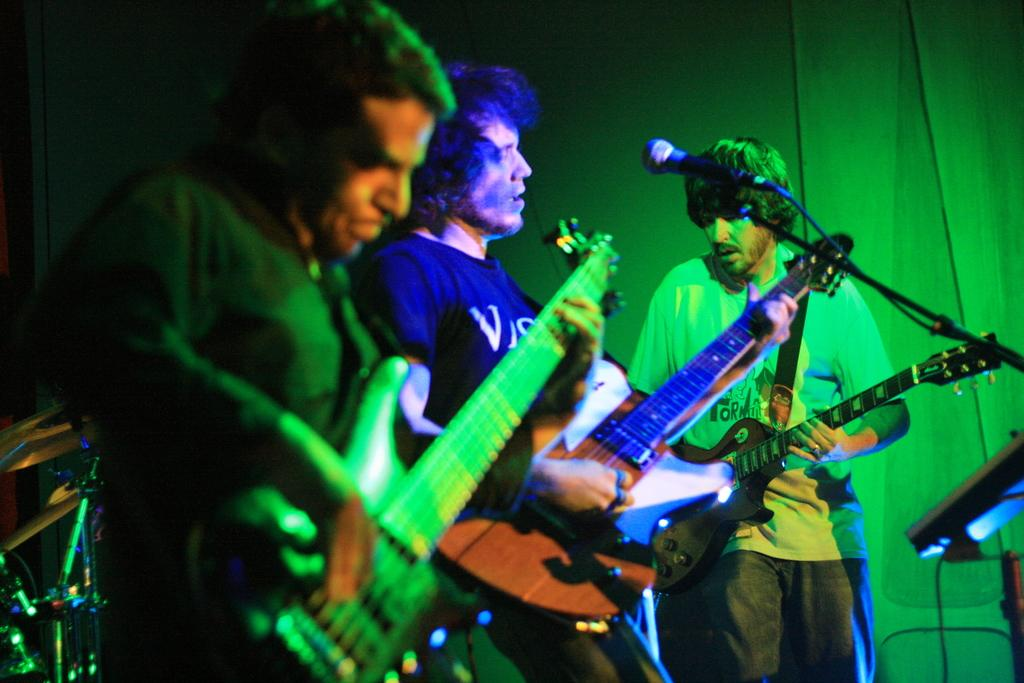How many people are in the image? There are three persons in the image. What are the three persons doing? They are playing guitar. Can you describe the middle person in the image? The middle person is holding a microphone. What type of quartz can be seen in the image? There is no quartz present in the image. What day of the week is depicted in the image? The image does not show a calendar or any indication of the day of the week. 